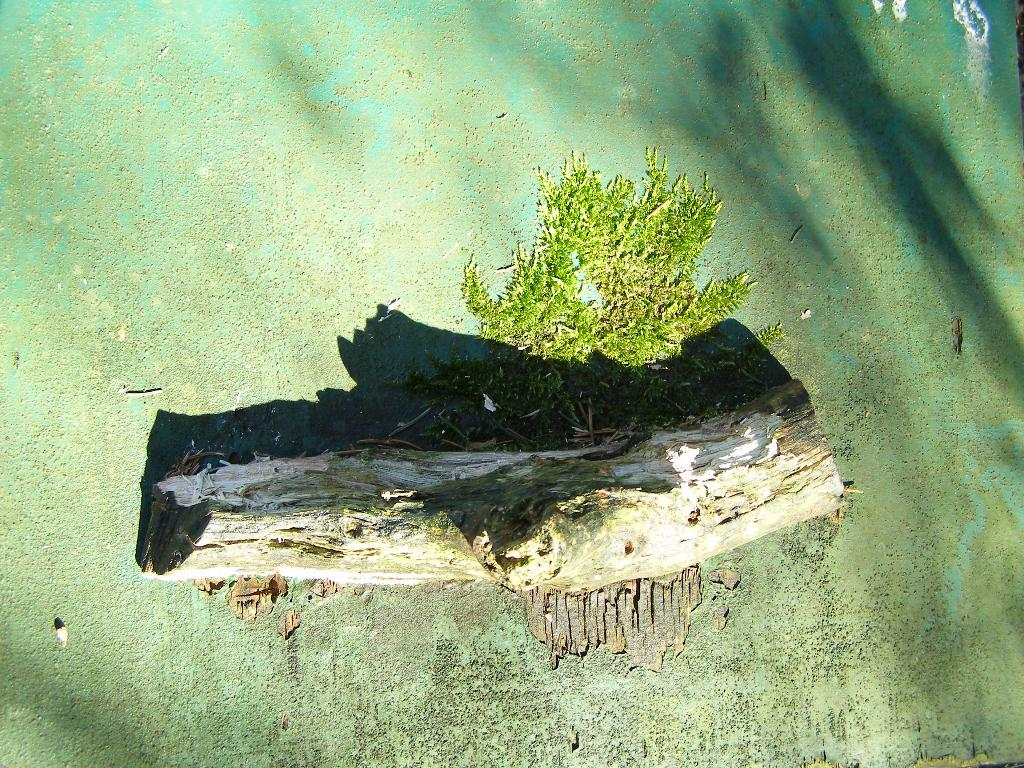What type of material is the log in the image made of? The wooden log in the image is made of wood. What color is the object in the image? The object in the image is green. Where is the green object located in the image? The green object is on a green surface. How many visitors are present in the image? There is no indication of any visitors in the image. What type of rose can be seen in the image? There is no rose present in the image. 